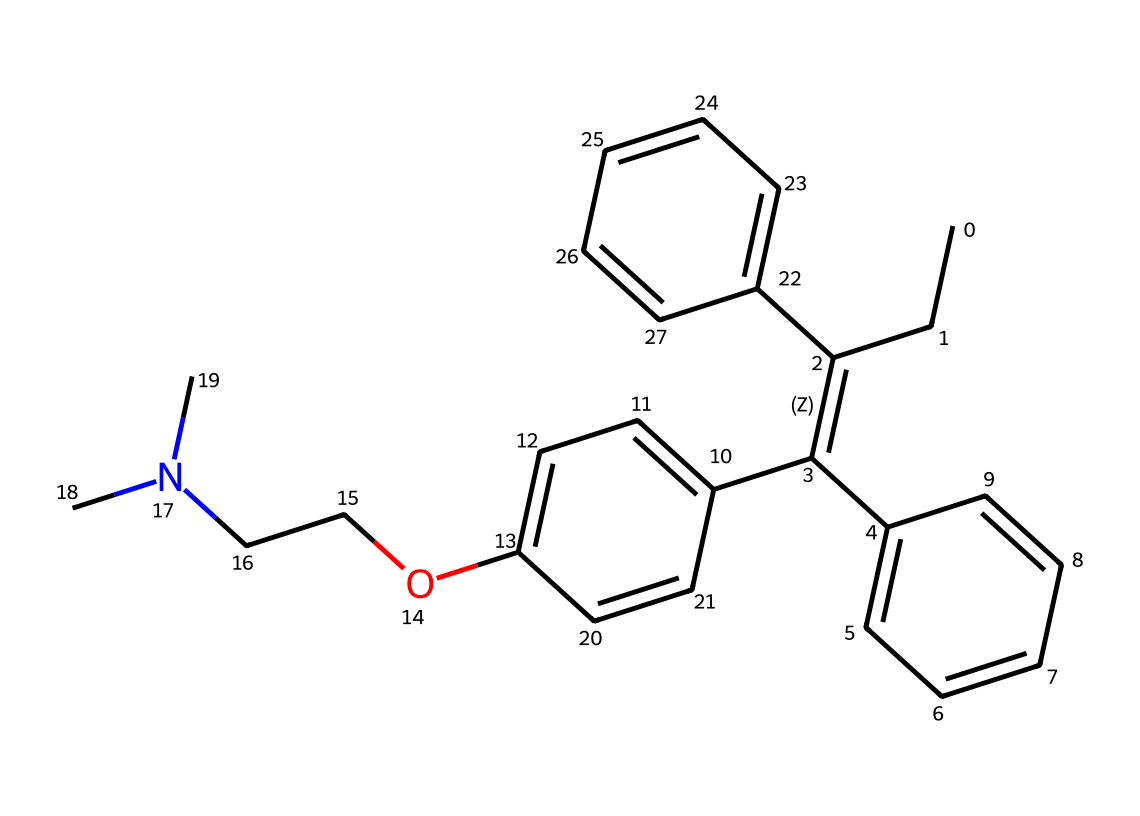What is the molecular formula of tamoxifen? To determine the molecular formula, we need to count the number of each type of atom present in the SMILES representation. The structure contains 26 carbons (C), 29 hydrogens (H), 1 oxygen (O), and 1 nitrogen (N). Arranging these gives C26H29NO.
Answer: C26H29NO How many aromatic rings are present in tamoxifen? By examining the SMILES structure, we identify two benzene rings (aromatic rings), both of which are represented as "c" (for aromatic carbons). Thus, the answer is two.
Answer: 2 What functional group is present in tamoxifen? In the provided SMILES notation, the presence of "O" indicates a phenolic hydroxyl (-OH) group, which is a functional group. Additionally, the tertiary amine is indicated by "N(C)C". Therefore, the primary functional group we identify here is the hydroxyl group.
Answer: hydroxyl How many nitrogen atoms are in tamoxifen? From the SMILES structure, we can identify a single "N" representing one nitrogen atom. No additional nitrogens are indicated elsewhere in the representation, making the count one.
Answer: 1 Which part of the chemical contributes to its estrogen receptor modulation? The stilbene structure in the middle part of the SMILES leads to modifications of estrogen receptors. This part, particularly the double bond and the adjacent aromatic systems, plays a crucial role in its interaction with estrogen receptors.
Answer: stilbene Is tamoxifen a polar or non-polar compound? Analyzing the presence of functional groups and their implications on polarity, the hydroxyl (-OH) group adds some polarity due to hydrogen bonding capabilities, but the large hydrocarbon portion leads to a non-polar character overall. Thus, tamoxifen tends toward being less polar on balance.
Answer: non-polar 